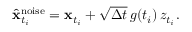Convert formula to latex. <formula><loc_0><loc_0><loc_500><loc_500>\begin{array} { r } { \hat { x } _ { t _ { i } } ^ { n o i s e } = x _ { t _ { i } } + \sqrt { \Delta t } \, g ( t _ { i } ) \, z _ { t _ { i } } . } \end{array}</formula> 